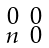<formula> <loc_0><loc_0><loc_500><loc_500>\begin{smallmatrix} 0 & 0 \\ n & 0 \end{smallmatrix}</formula> 